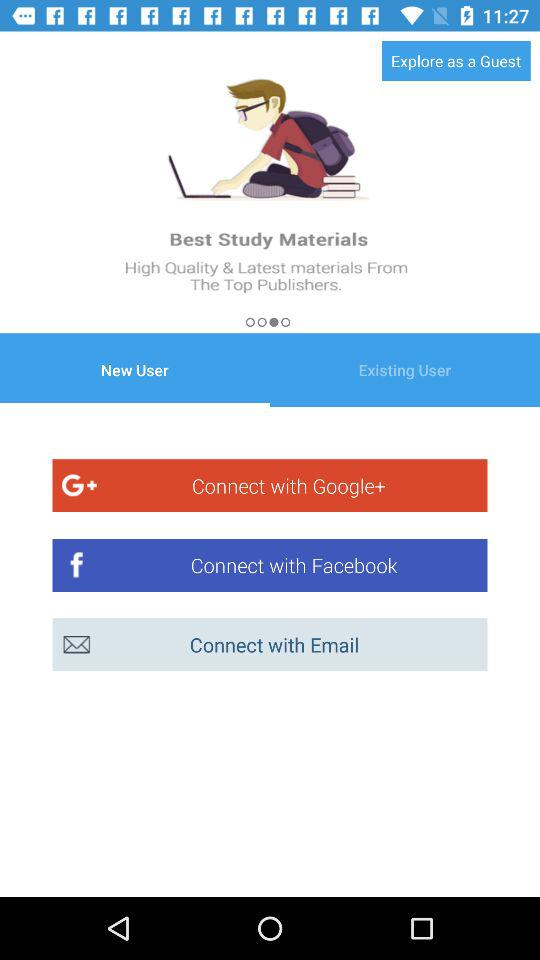Which tab is selected? The selected tab is "New User". 